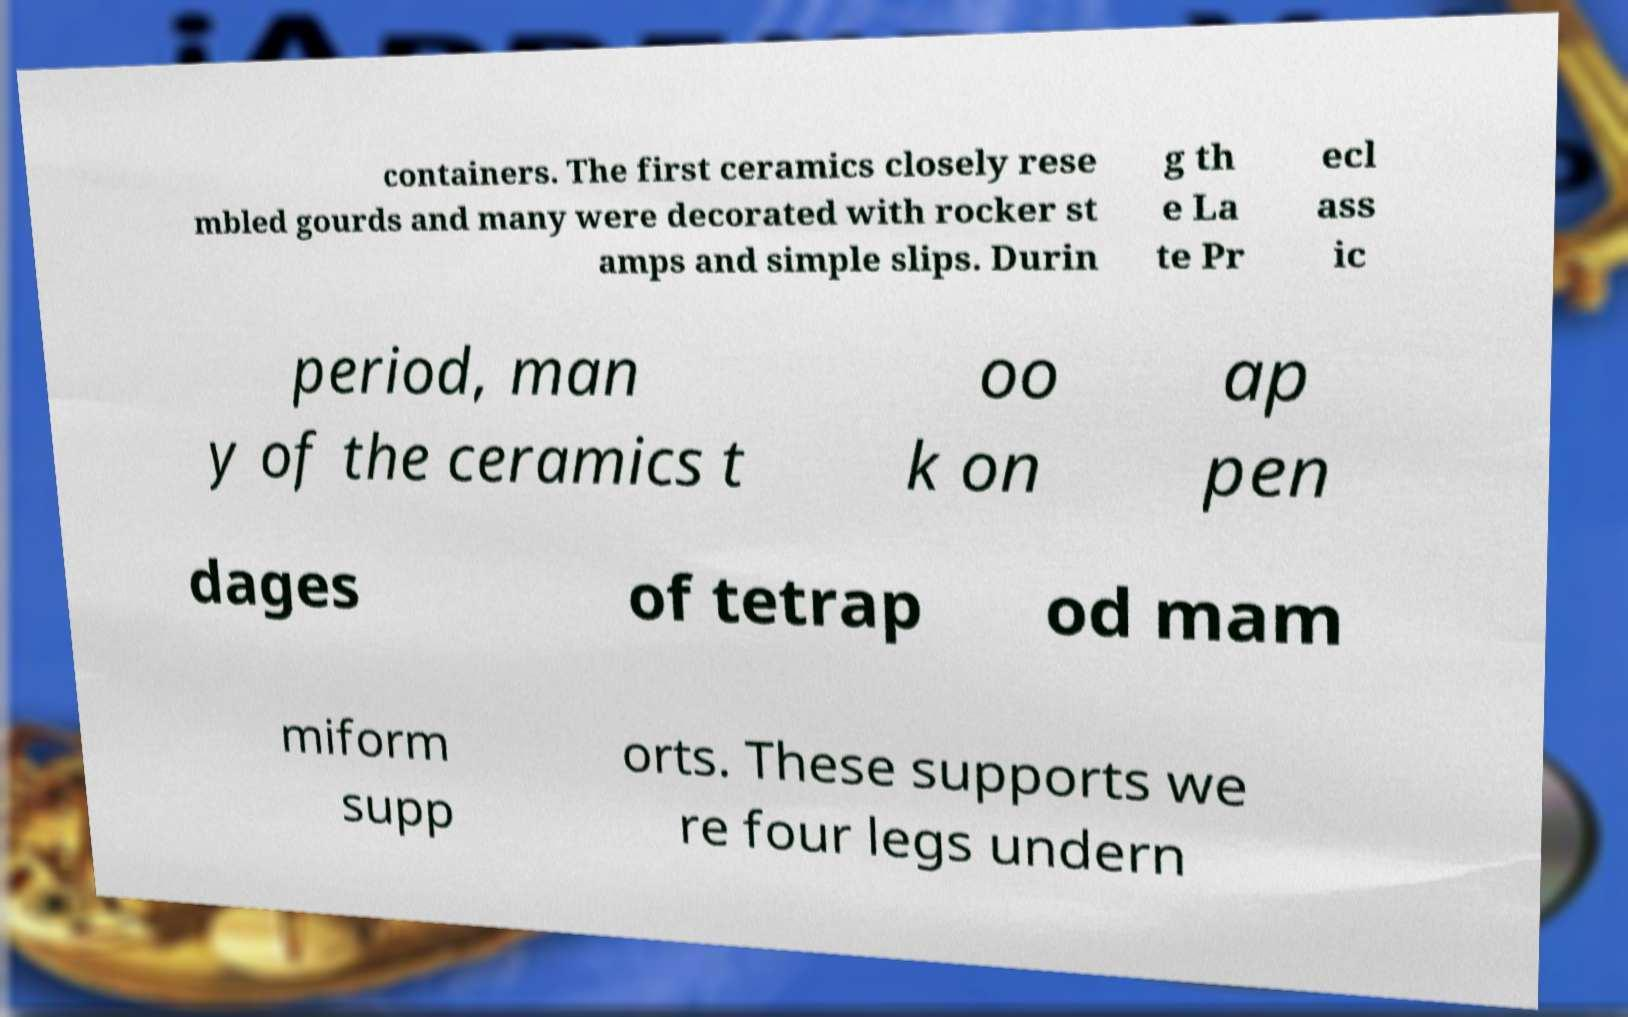Please read and relay the text visible in this image. What does it say? containers. The first ceramics closely rese mbled gourds and many were decorated with rocker st amps and simple slips. Durin g th e La te Pr ecl ass ic period, man y of the ceramics t oo k on ap pen dages of tetrap od mam miform supp orts. These supports we re four legs undern 